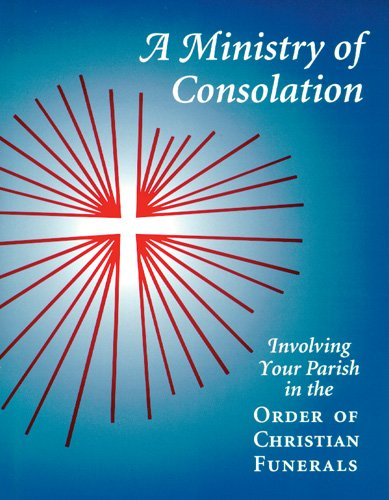What is the title of this book? The title of the book shown in the image is 'A Ministry of Consolation: Involving Your Parish in the Order of Christian Funerals (Ministry Series)'. 